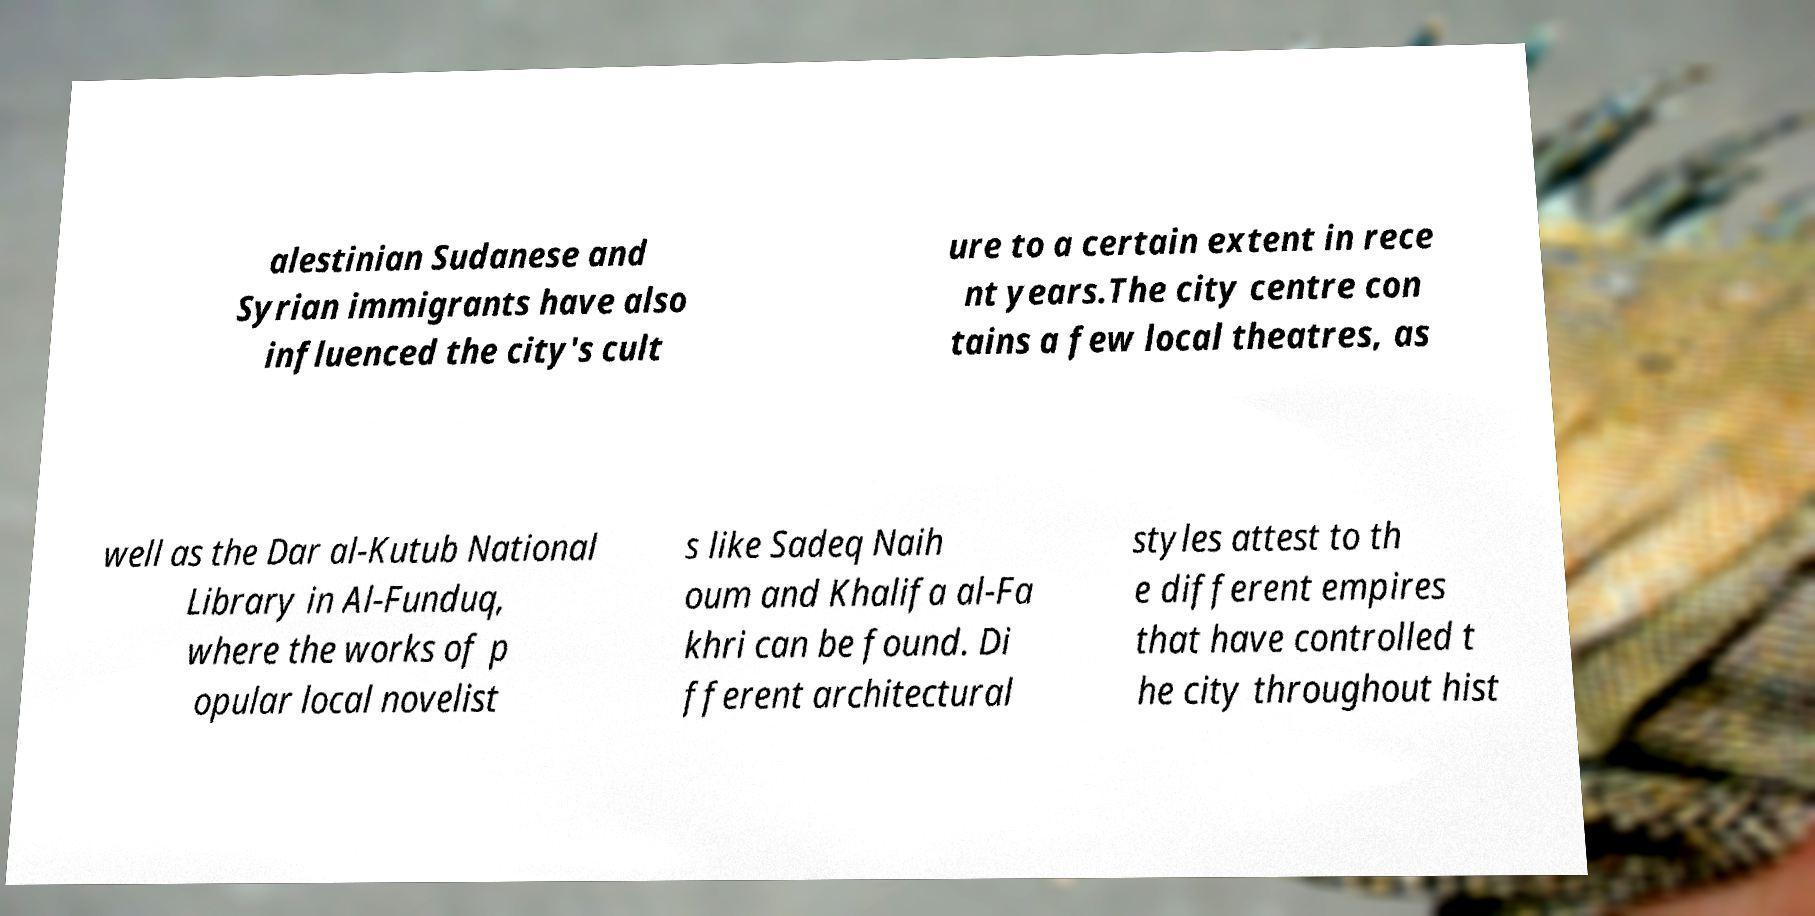Can you accurately transcribe the text from the provided image for me? alestinian Sudanese and Syrian immigrants have also influenced the city's cult ure to a certain extent in rece nt years.The city centre con tains a few local theatres, as well as the Dar al-Kutub National Library in Al-Funduq, where the works of p opular local novelist s like Sadeq Naih oum and Khalifa al-Fa khri can be found. Di fferent architectural styles attest to th e different empires that have controlled t he city throughout hist 